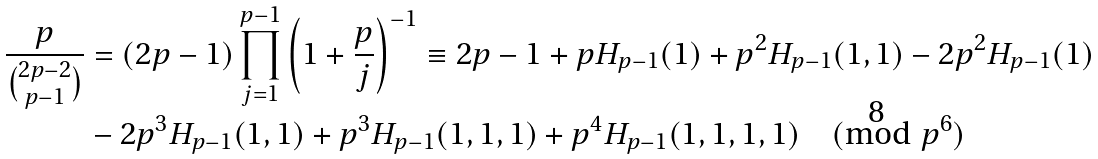Convert formula to latex. <formula><loc_0><loc_0><loc_500><loc_500>\frac { p } { \binom { 2 p - 2 } { p - 1 } } & = ( 2 p - 1 ) \prod _ { j = 1 } ^ { p - 1 } \left ( 1 + \frac { p } { j } \right ) ^ { - 1 } \equiv 2 p - 1 + p H _ { p - 1 } ( 1 ) + p ^ { 2 } H _ { p - 1 } ( 1 , 1 ) - 2 p ^ { 2 } H _ { p - 1 } ( 1 ) \\ & - 2 p ^ { 3 } H _ { p - 1 } ( 1 , 1 ) + p ^ { 3 } H _ { p - 1 } ( 1 , 1 , 1 ) + p ^ { 4 } H _ { p - 1 } ( 1 , 1 , 1 , 1 ) \pmod { p ^ { 6 } }</formula> 